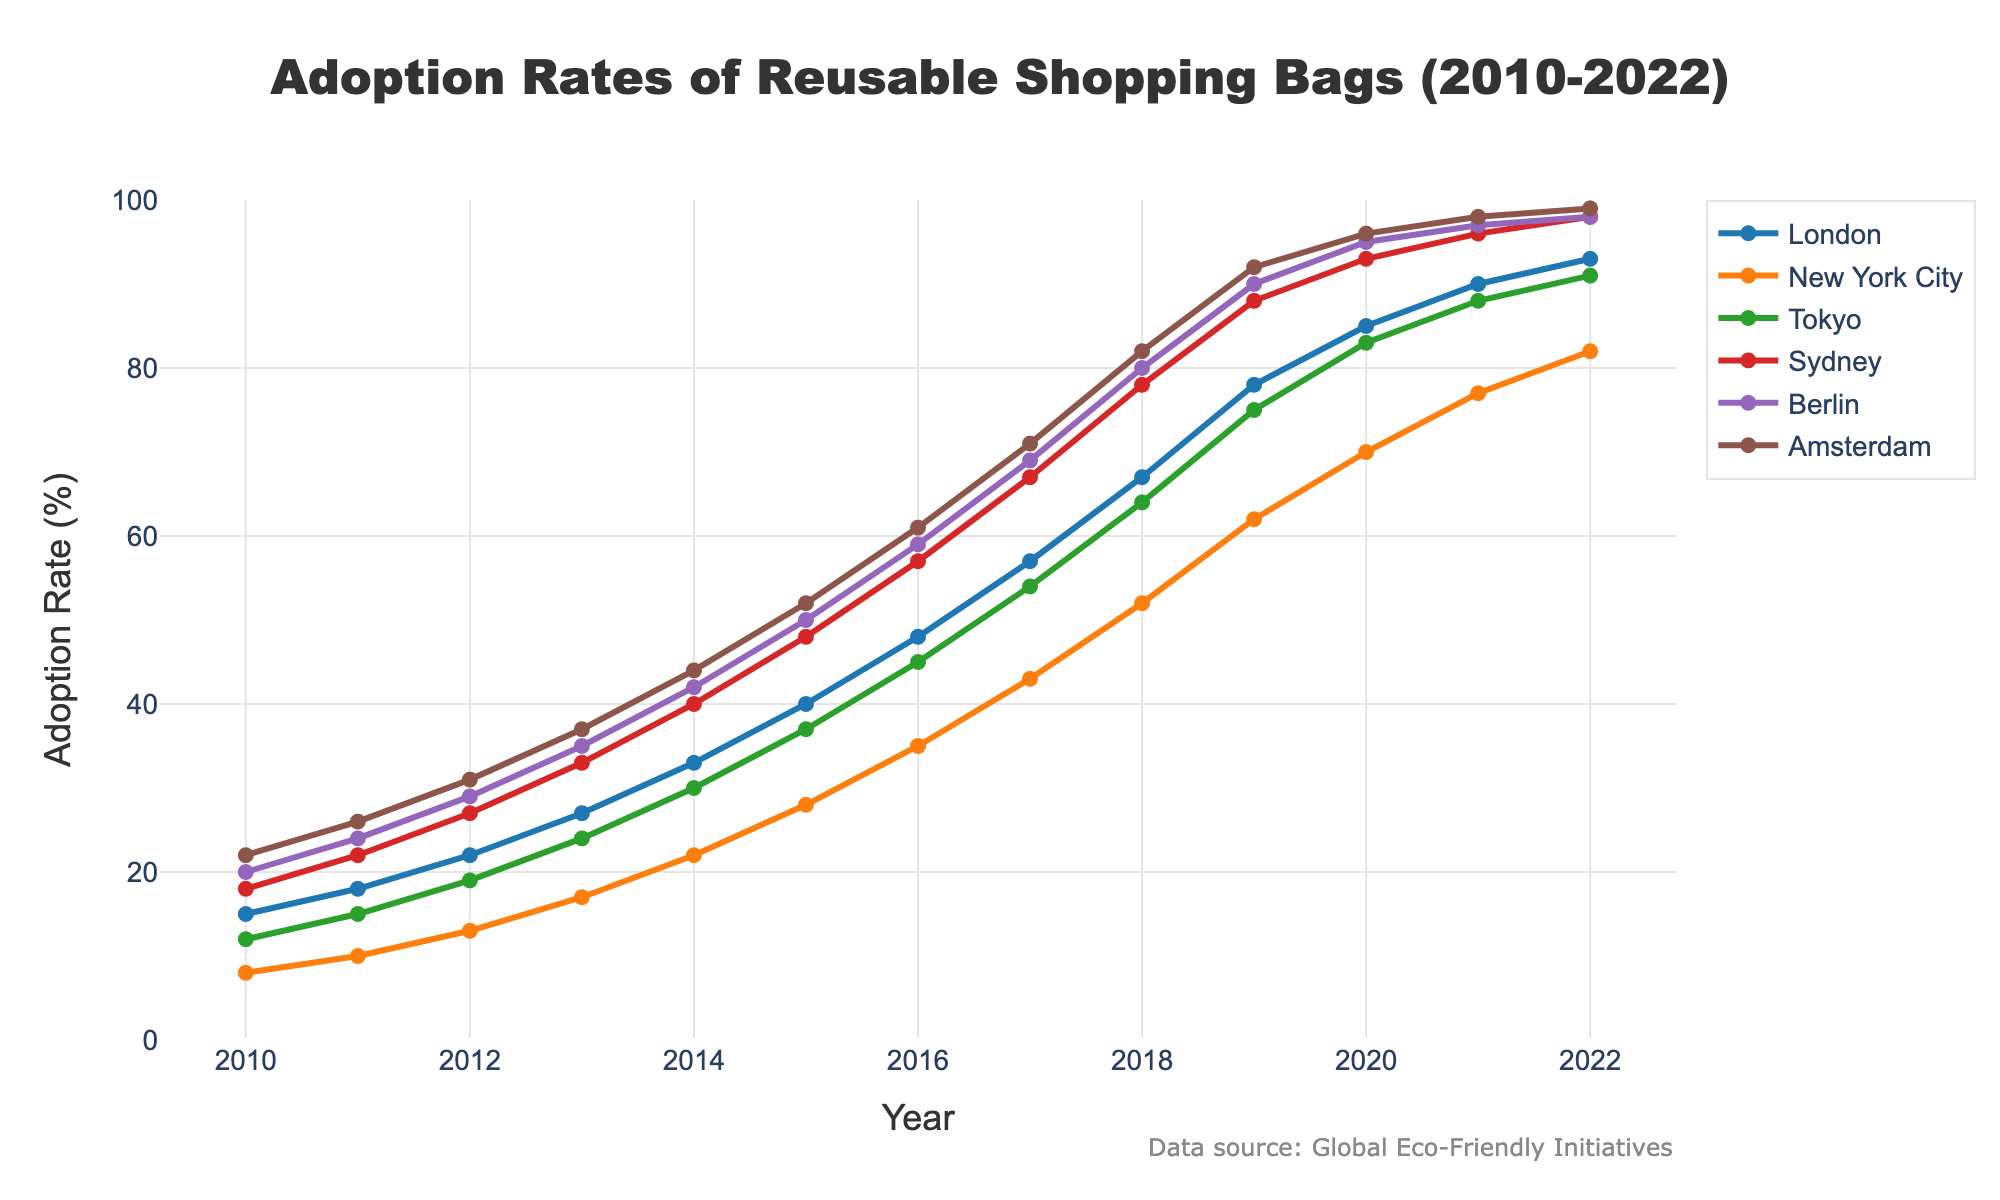Which city had the highest adoption rate of reusable shopping bags in 2022? In the figure, look at the points for 2022 and identify the city with the highest point. Berlin and Amsterdam both have the highest adoption rates of reusable shopping bags at 98% and 99%, respectively.
Answer: Amsterdam Which city showed the largest increase in adoption rate of reusable shopping bags from 2010 to 2022? Calculate the difference between the adoption rate in 2022 and 2010 for each city. The largest positive difference indicates the city with the largest increase. London increased from 15% to 93%, resulting in a 78% increase.
Answer: London What's the average adoption rate of reusable shopping bags across all cities in 2018? Sum the adoption rates of all cities in 2018 and divide by the total number of cities (6). The adoption rates are 67 (London), 52 (New York City), 64 (Tokyo), 78 (Sydney), 80 (Berlin), and 82 (Amsterdam). Average = (67+52+64+78+80+82)/6 = 423/6.
Answer: 70.5 Which city had a steeper adoption rate curve between 2010 and 2015: Tokyo or Sydney? Compare the slopes of the lines for Tokyo and Sydney from 2010 to 2015 by examining the rate of increase in adoption rates over these years. Tokyo increased from 12% to 37%, a difference of 25%. Sydney increased from 18% to 48%, a difference of 30%. Sydney's curve is steeper as it showed a larger increase.
Answer: Sydney In which year did London surpass a 50% adoption rate? Identify the year on the x-axis where London's adoption rate line crosses the 50% threshold. In the figure, London's point for 2016 shows an adoption rate of 48%, and in 2017 it shows 57%. Thus, London surpassed the 50% mark in 2017.
Answer: 2017 How does the adoption rate trend of New York City compare to that of Berlin? Look at the lines representing New York City and Berlin and compare their trends. Berlin has a consistently higher adoption rate and a steeper upward trend compared to New York City, which increases at a slower rate.
Answer: Berlin’s adoption rate increased more rapidly What's the difference in adoption rates between Tokyo and Amsterdam in 2020? Find the adoption rates of Tokyo and Amsterdam in 2020 from the figure and compute the difference. Tokyo's adoption rate is 83% and Amsterdam's adoption rate is 96%, so the difference is 96 - 83.
Answer: 13 Which city reached around 90% adoption rate of reusable shopping bags first? Look at the adoption rate lines for each city and identify which city hits approximately 90% first. Berlin reaches 90% adoption in 2019, while others are either not yet there or surpass it later.
Answer: Berlin For New York City, what is the median adoption rate of reusable shopping bags from 2010 to 2018? Extract the adoption rates for New York City from the figure for the years 2010 to 2018. The values are 8, 10, 13, 17, 22, 28, 35, 43, 52. The median of these sorted values (10, 13, 17, 22, 28, 35, 43, 52) is the middle value since there are 9 numbers. The middle value here is 28.
Answer: 28 Between which pair of consecutive years did Sydney experience the highest increase in adoption rate? Compare the adoption rate differences year-over-year for Sydney. The highest increase is observed between 2018 (78%) and 2019 (88%), which is a 10% increase.
Answer: 2018 and 2019 